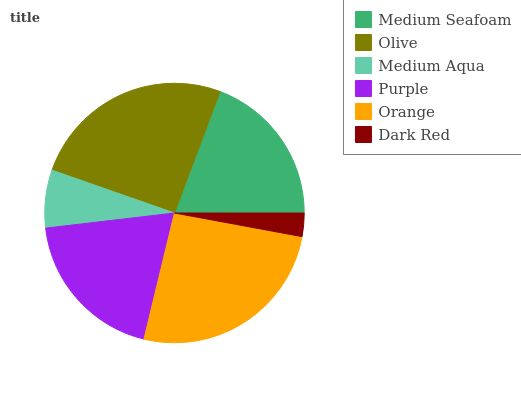Is Dark Red the minimum?
Answer yes or no. Yes. Is Orange the maximum?
Answer yes or no. Yes. Is Olive the minimum?
Answer yes or no. No. Is Olive the maximum?
Answer yes or no. No. Is Olive greater than Medium Seafoam?
Answer yes or no. Yes. Is Medium Seafoam less than Olive?
Answer yes or no. Yes. Is Medium Seafoam greater than Olive?
Answer yes or no. No. Is Olive less than Medium Seafoam?
Answer yes or no. No. Is Purple the high median?
Answer yes or no. Yes. Is Medium Seafoam the low median?
Answer yes or no. Yes. Is Olive the high median?
Answer yes or no. No. Is Olive the low median?
Answer yes or no. No. 